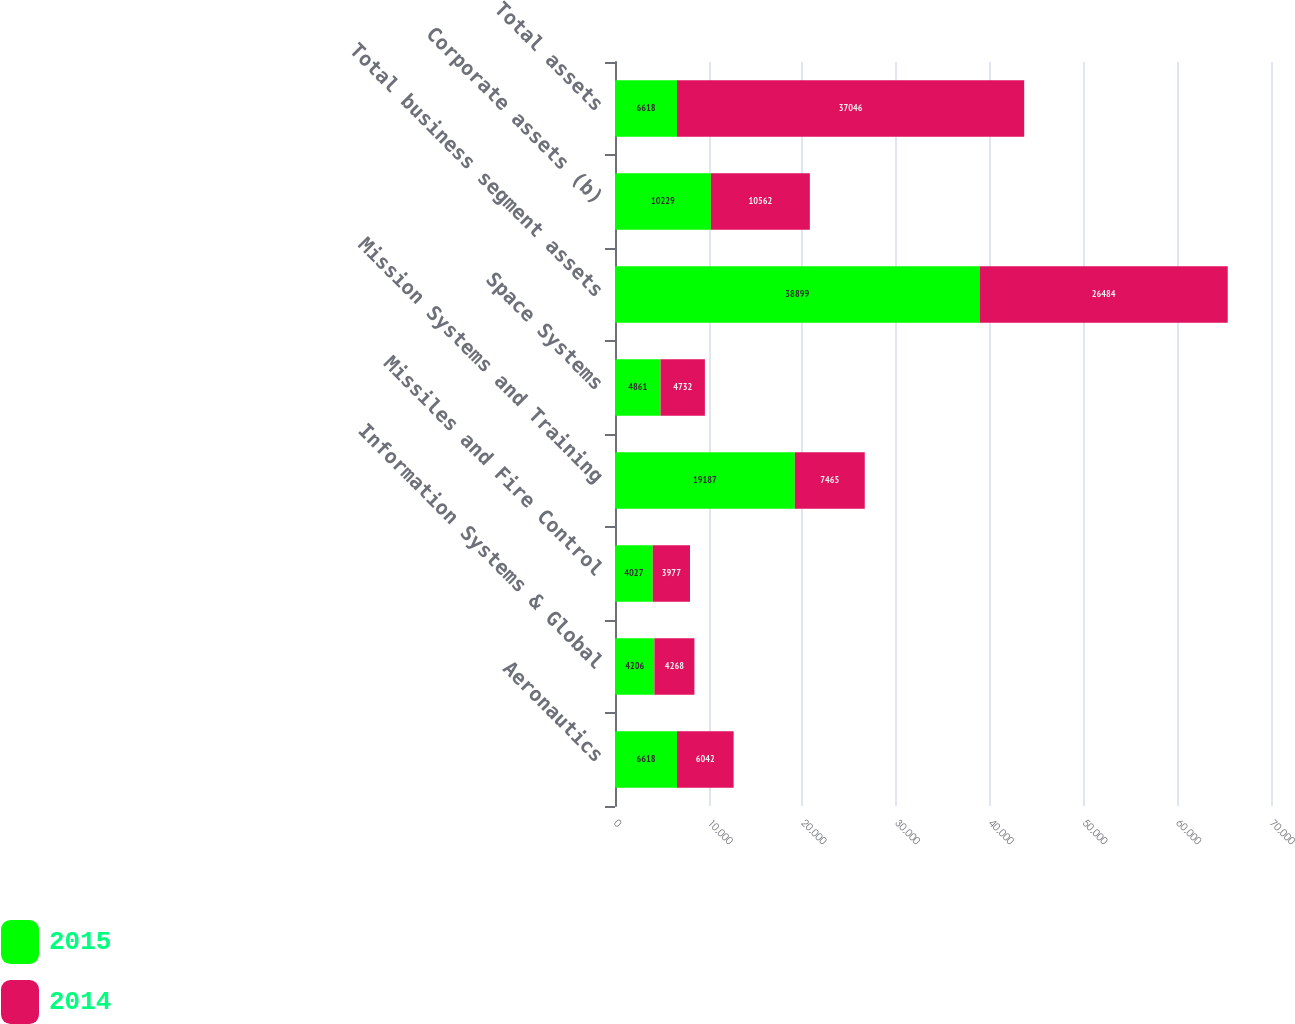Convert chart to OTSL. <chart><loc_0><loc_0><loc_500><loc_500><stacked_bar_chart><ecel><fcel>Aeronautics<fcel>Information Systems & Global<fcel>Missiles and Fire Control<fcel>Mission Systems and Training<fcel>Space Systems<fcel>Total business segment assets<fcel>Corporate assets (b)<fcel>Total assets<nl><fcel>2015<fcel>6618<fcel>4206<fcel>4027<fcel>19187<fcel>4861<fcel>38899<fcel>10229<fcel>6618<nl><fcel>2014<fcel>6042<fcel>4268<fcel>3977<fcel>7465<fcel>4732<fcel>26484<fcel>10562<fcel>37046<nl></chart> 